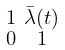Convert formula to latex. <formula><loc_0><loc_0><loc_500><loc_500>\begin{smallmatrix} 1 & \bar { \lambda } ( t ) \\ 0 & 1 \end{smallmatrix}</formula> 